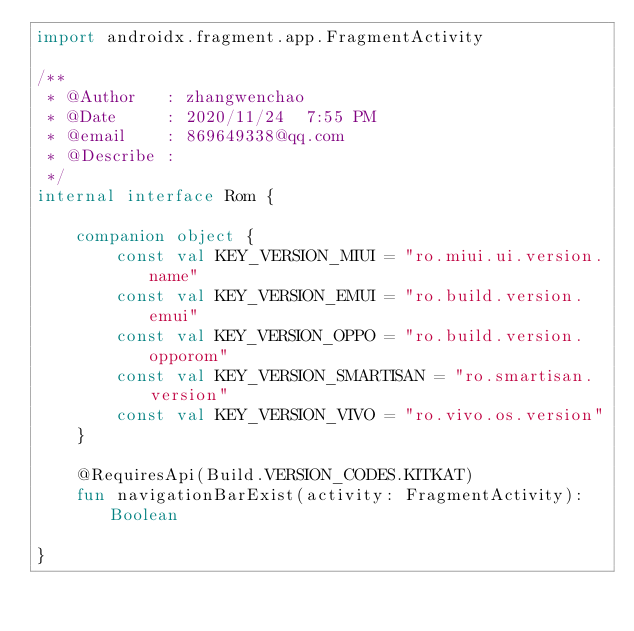<code> <loc_0><loc_0><loc_500><loc_500><_Kotlin_>import androidx.fragment.app.FragmentActivity

/**
 * @Author   : zhangwenchao
 * @Date     : 2020/11/24  7:55 PM
 * @email    : 869649338@qq.com
 * @Describe :
 */
internal interface Rom {

    companion object {
        const val KEY_VERSION_MIUI = "ro.miui.ui.version.name"
        const val KEY_VERSION_EMUI = "ro.build.version.emui"
        const val KEY_VERSION_OPPO = "ro.build.version.opporom"
        const val KEY_VERSION_SMARTISAN = "ro.smartisan.version"
        const val KEY_VERSION_VIVO = "ro.vivo.os.version"
    }

    @RequiresApi(Build.VERSION_CODES.KITKAT)
    fun navigationBarExist(activity: FragmentActivity): Boolean

}</code> 